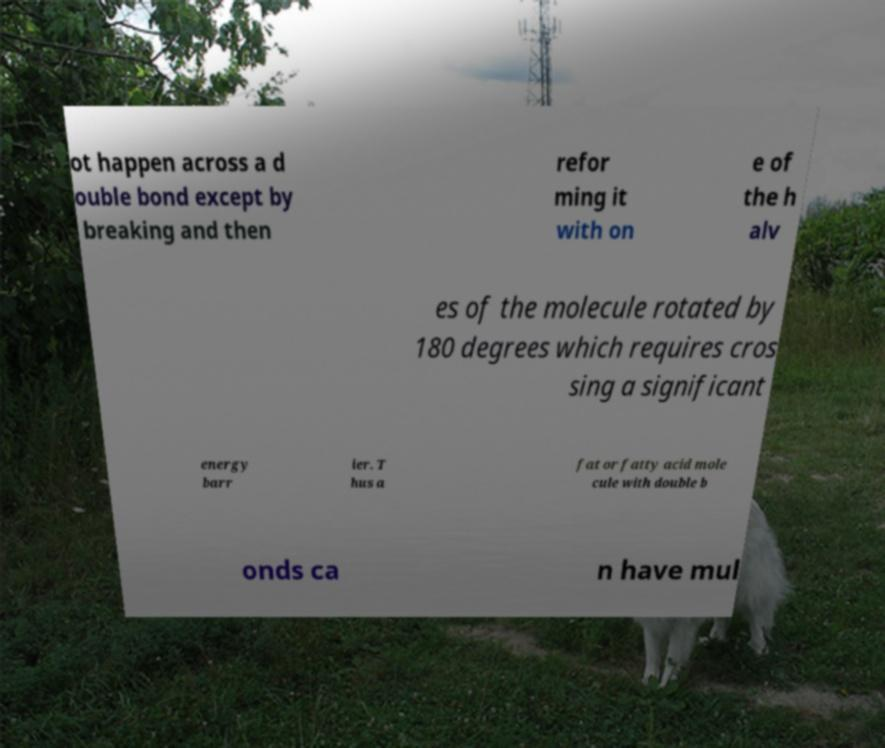I need the written content from this picture converted into text. Can you do that? ot happen across a d ouble bond except by breaking and then refor ming it with on e of the h alv es of the molecule rotated by 180 degrees which requires cros sing a significant energy barr ier. T hus a fat or fatty acid mole cule with double b onds ca n have mul 